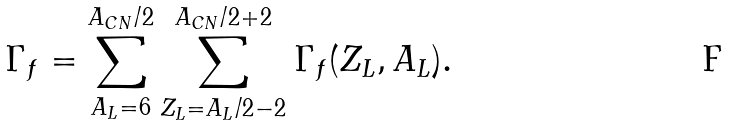<formula> <loc_0><loc_0><loc_500><loc_500>\Gamma _ { f } = \sum ^ { A _ { C N } / 2 } _ { A _ { L } = 6 } \sum ^ { A _ { C N } / 2 + 2 } _ { Z _ { L } = A _ { L } / 2 - 2 } \Gamma _ { f } ( Z _ { L } , A _ { L } ) .</formula> 